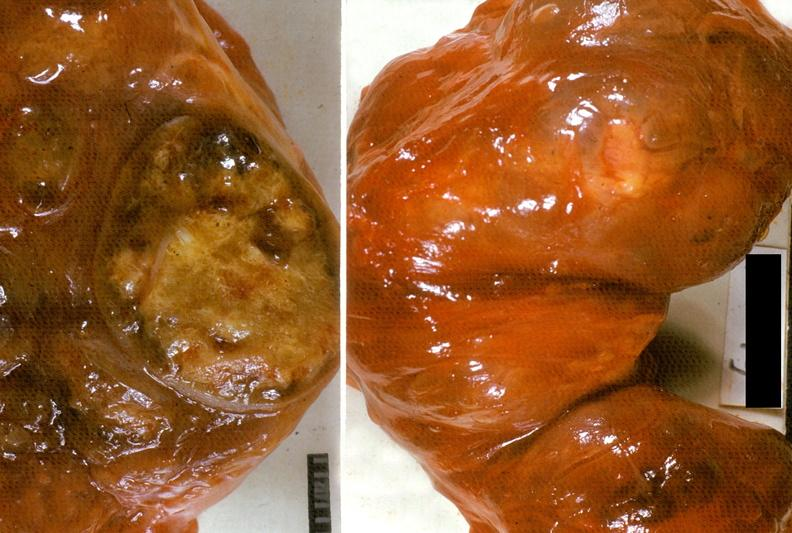where does this belong to?
Answer the question using a single word or phrase. Endocrine system 